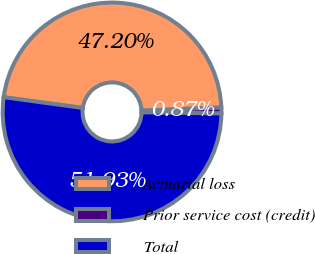Convert chart to OTSL. <chart><loc_0><loc_0><loc_500><loc_500><pie_chart><fcel>Actuarial loss<fcel>Prior service cost (credit)<fcel>Total<nl><fcel>47.2%<fcel>0.87%<fcel>51.92%<nl></chart> 